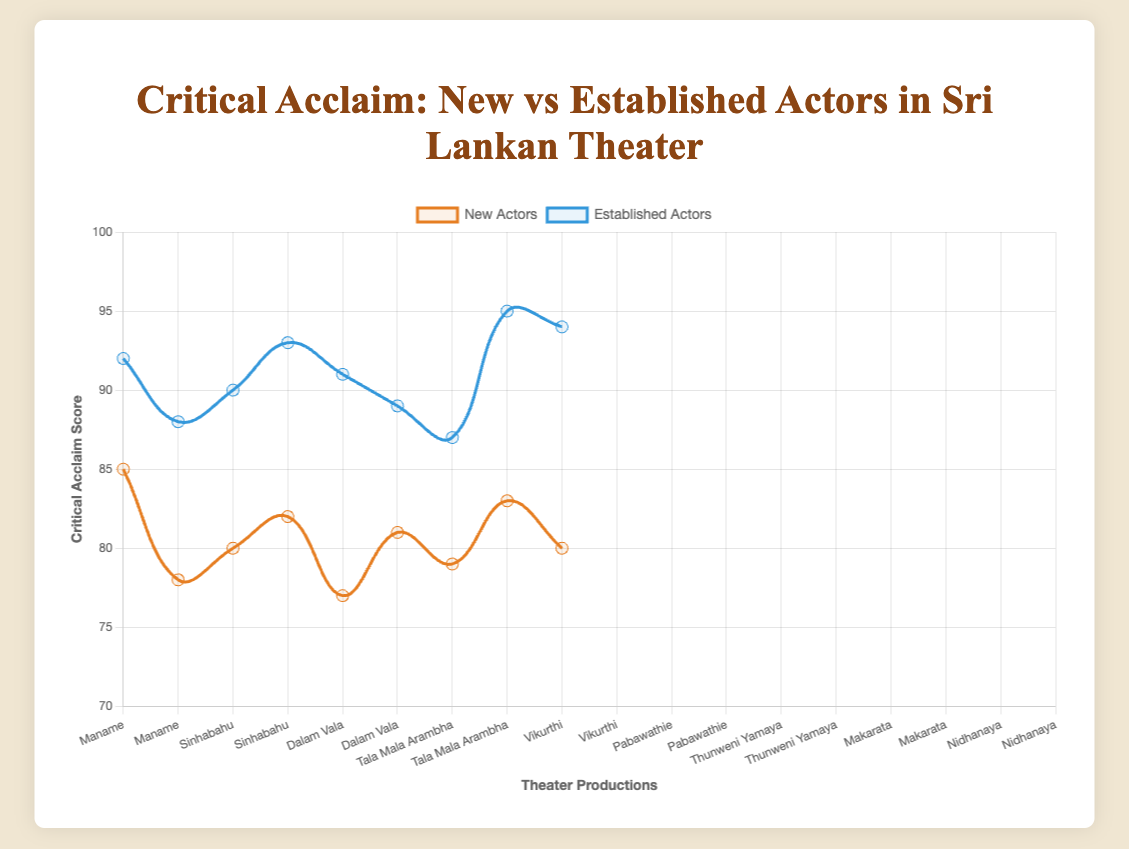How do the critical acclaim scores for new vs established actors compare in the production "Maname"? In the production "Maname", Nadun Dole (new actor) has a score of 85, while Chandani Seneviratne (established actor) has a score of 92. The established actor has a higher score.
Answer: Established actor has a higher score What is the average critical acclaim score for new actors? The scores for new actors are 85, 78, 80, 82, 77, 81, 79, 83, 80. Adding these gives a total of 725. There are 9 new actors, so the average score is 725/9.
Answer: 80.56 Which actor received the highest critical acclaim score among both new and established actors? The highest critical acclaim score is 95, which was received by Vijaya Kumaratunga (established actor) in the production "Makarata".
Answer: Vijaya Kumaratunga In which production did the new actor receive the lowest critical acclaim score? The new actor with the lowest critical acclaim score is Anarkali Akarsha with a score of 77 in the production "Vikurthi".
Answer: Vikurthi By how much does the average critical acclaim score for established actors exceed that for new actors? The scores for established actors are 92, 88, 90, 93, 91, 89, 87, 95, 94. Adding these gives a total of 809. There are 9 established actors, so the average score is 809/9 = 89.89. The average score for new actors is 80.56. The difference is 89.89 - 80.56.
Answer: 9.33 Which production has the highest critical acclaim score for an established actor? The highest score for an established actor is 95 by Vijaya Kumaratunga in "Makarata".
Answer: Makarata What is the range of critical acclaim scores for new actors? The scores for new actors range from 77 to 85. The range is 85 - 77.
Answer: 8 Are there any productions where the new actor has a higher critical acclaim score than the established actor? No, in all productions, established actors have higher or equal scores compared to new actors.
Answer: No What is the sum of critical acclaim scores of all actors in production "Sinhabahu"? Jackson Anthony (established) has a score of 88 and Himali Sayurangi (new) has a score of 78. The total score is 88 + 78.
Answer: 166 